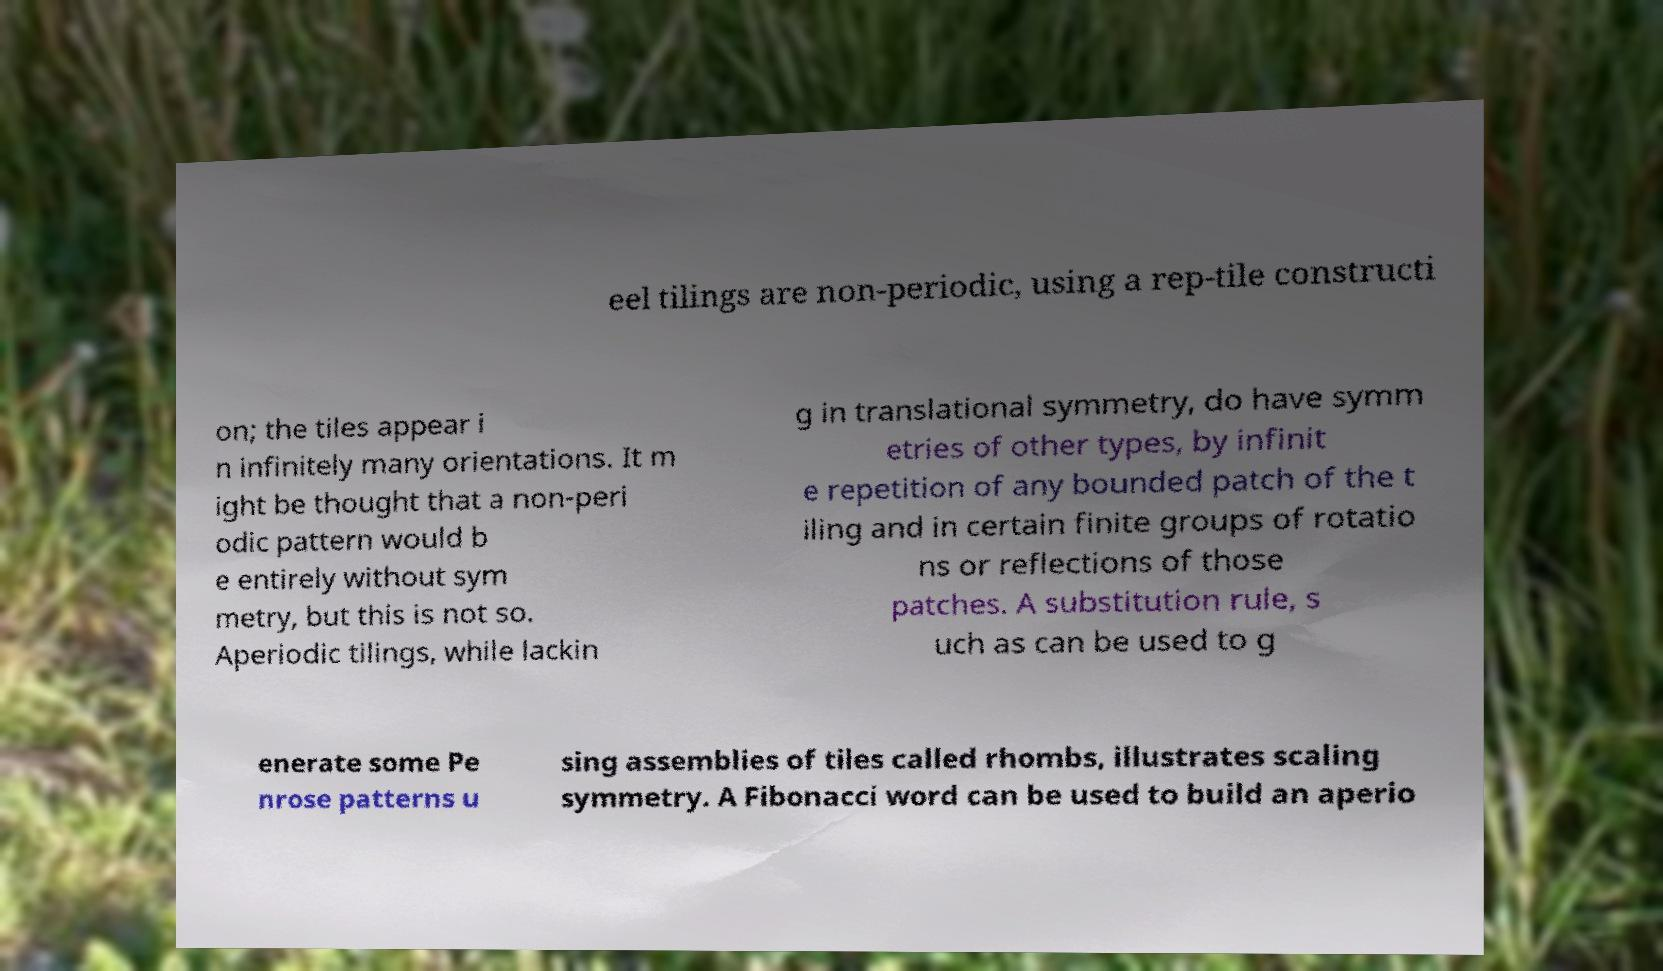Could you assist in decoding the text presented in this image and type it out clearly? eel tilings are non-periodic, using a rep-tile constructi on; the tiles appear i n infinitely many orientations. It m ight be thought that a non-peri odic pattern would b e entirely without sym metry, but this is not so. Aperiodic tilings, while lackin g in translational symmetry, do have symm etries of other types, by infinit e repetition of any bounded patch of the t iling and in certain finite groups of rotatio ns or reflections of those patches. A substitution rule, s uch as can be used to g enerate some Pe nrose patterns u sing assemblies of tiles called rhombs, illustrates scaling symmetry. A Fibonacci word can be used to build an aperio 